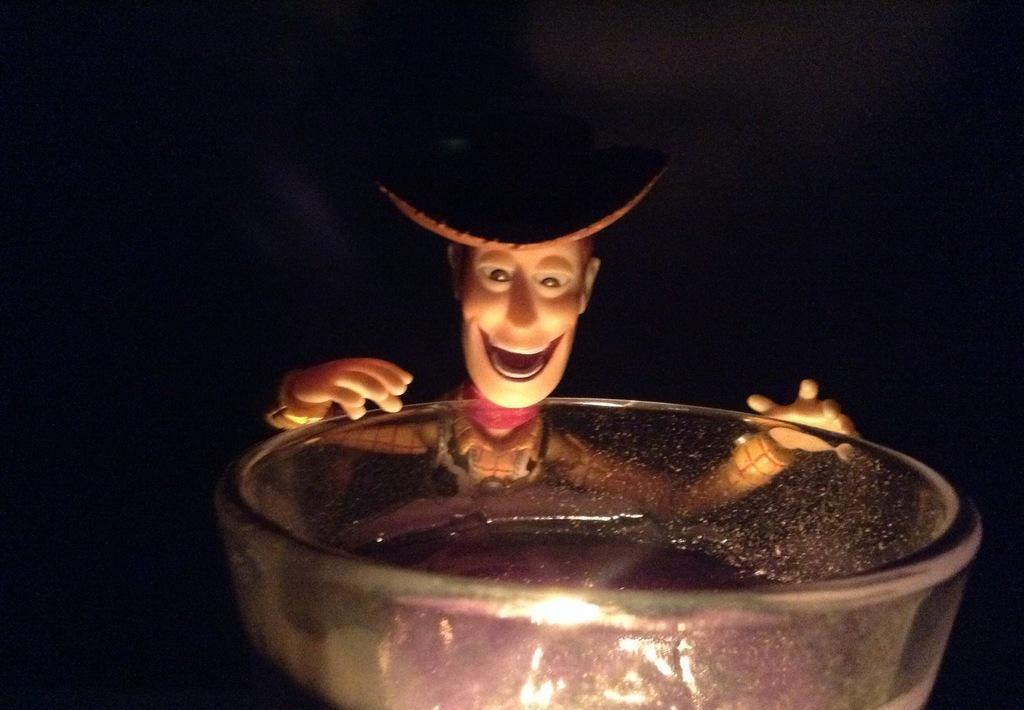Can you describe this image briefly? In this image I can see a bowl. I can see a toy. I can see the background is black in color. 